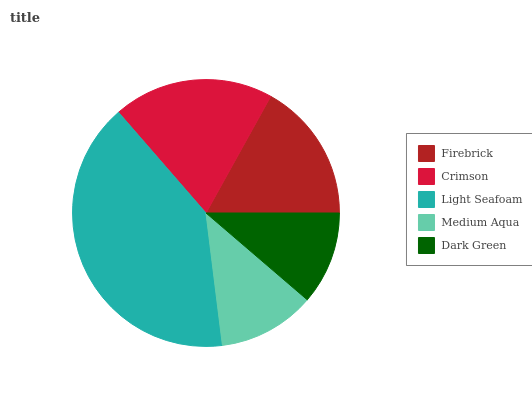Is Dark Green the minimum?
Answer yes or no. Yes. Is Light Seafoam the maximum?
Answer yes or no. Yes. Is Crimson the minimum?
Answer yes or no. No. Is Crimson the maximum?
Answer yes or no. No. Is Crimson greater than Firebrick?
Answer yes or no. Yes. Is Firebrick less than Crimson?
Answer yes or no. Yes. Is Firebrick greater than Crimson?
Answer yes or no. No. Is Crimson less than Firebrick?
Answer yes or no. No. Is Firebrick the high median?
Answer yes or no. Yes. Is Firebrick the low median?
Answer yes or no. Yes. Is Dark Green the high median?
Answer yes or no. No. Is Dark Green the low median?
Answer yes or no. No. 